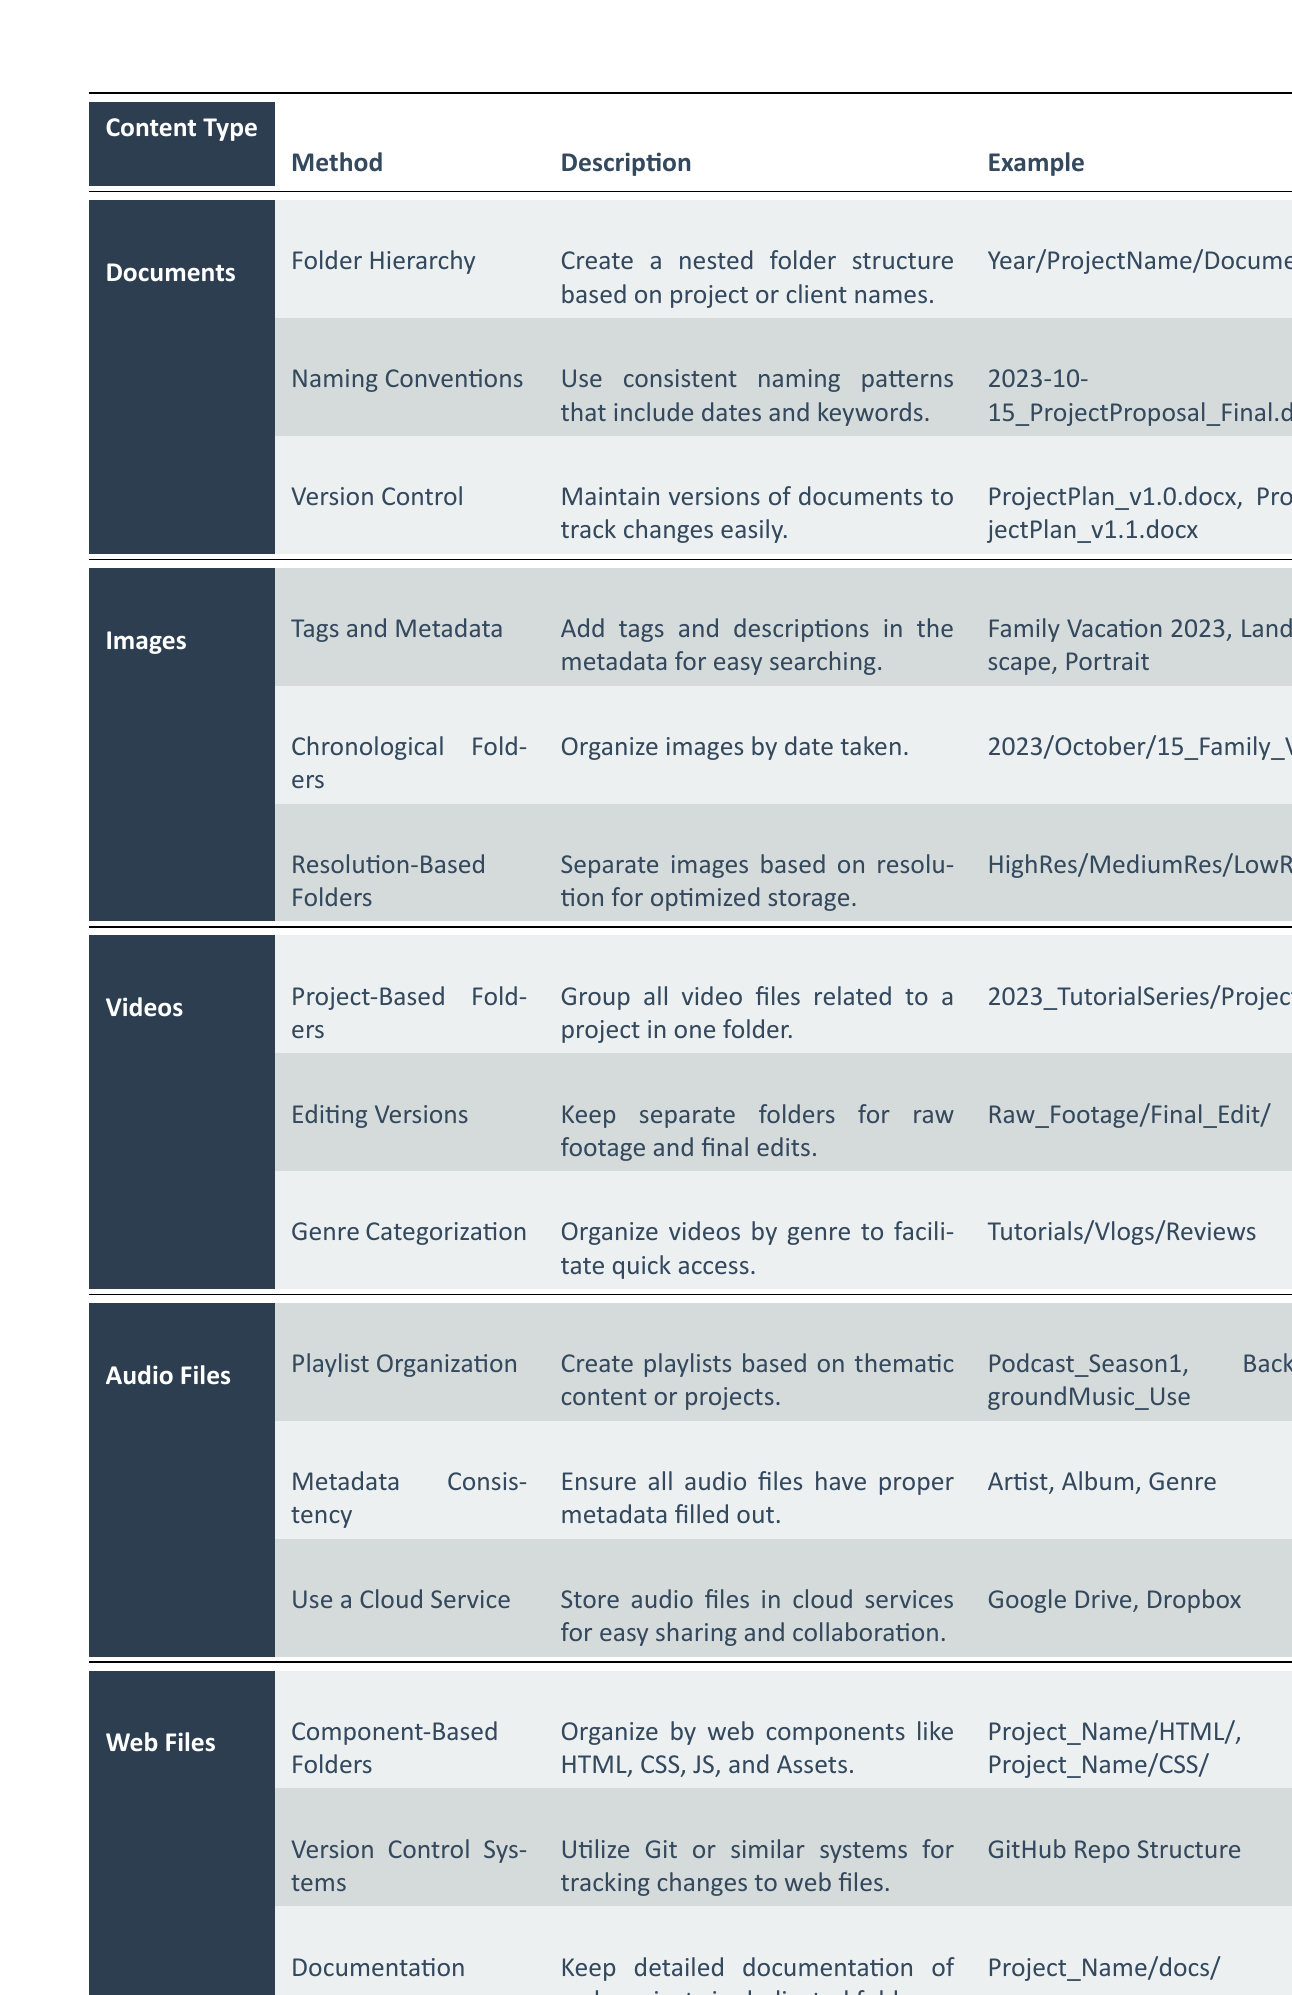What methods are suggested for organizing audio files? The table provides three methods for organizing audio files: Playlist Organization, Metadata Consistency, and Use a Cloud Service.
Answer: Playlist Organization, Metadata Consistency, Use a Cloud Service Which content type utilizes the technique of "Component-Based Folders"? The table indicates that "Component-Based Folders" is used for organizing Web Files.
Answer: Web Files Is "Version Control" mentioned as a technique for organizing Documents? Yes, the table shows that "Version Control" is indeed a technique for organizing Documents.
Answer: Yes What is one example of a method for organizing Images? The table lists "Tags and Metadata" as one method for organizing Images, for which an example is family vacation tags.
Answer: Tags and Metadata How many techniques are listed under the Videos category? There are three techniques listed under the Videos category: Project-Based Folders, Editing Versions, and Genre Categorization.
Answer: 3 Which technique under Documents includes examples of v1.0 and v1.1 file naming? The technique "Version Control" under Documents includes examples such as ProjectPlan_v1.0.docx and ProjectPlan_v1.1.docx.
Answer: Version Control Are there more techniques listed for Audio Files or Videos? The table shows that both Audio Files and Videos have three techniques each, making them equal in number.
Answer: Equal What type of folder method is used for organizing images chronologically? The method used for organizing images chronologically is called "Chronological Folders", where images are sorted by the date taken.
Answer: Chronological Folders How does the method "Genre Categorization" for Videos help with organization? "Genre Categorization" helps by grouping videos based on their genre, making it easier to access specific types quickly.
Answer: Easier access to specific types If I want to track changes in web files, which method should I use? To track changes in web files, you should use "Version Control Systems" as indicated in the table.
Answer: Version Control Systems 